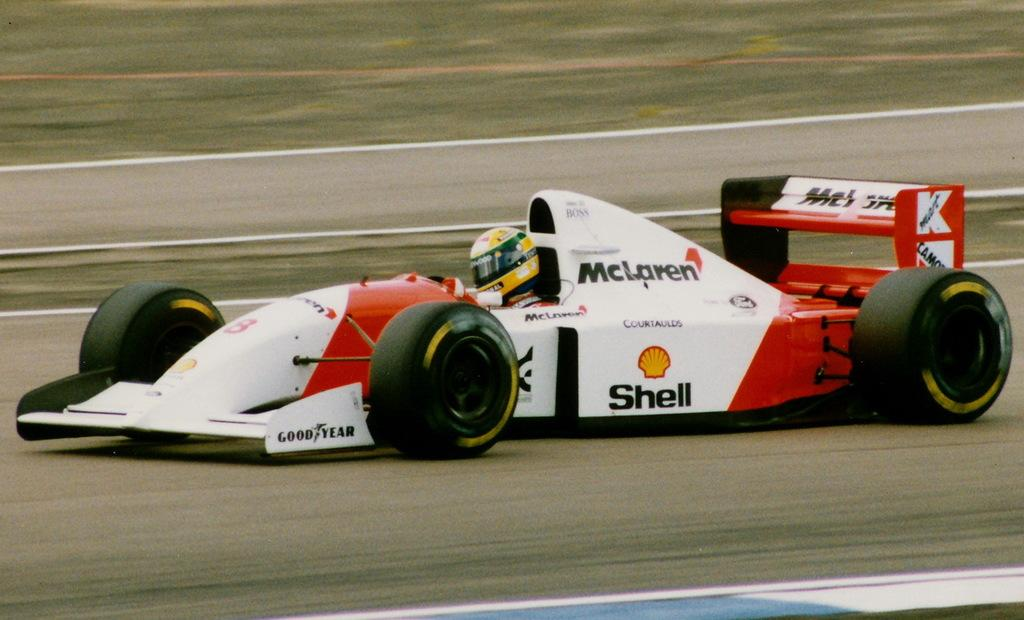Provide a one-sentence caption for the provided image. A red and white race car sponsored by Shell on the race track with the driver inside. 